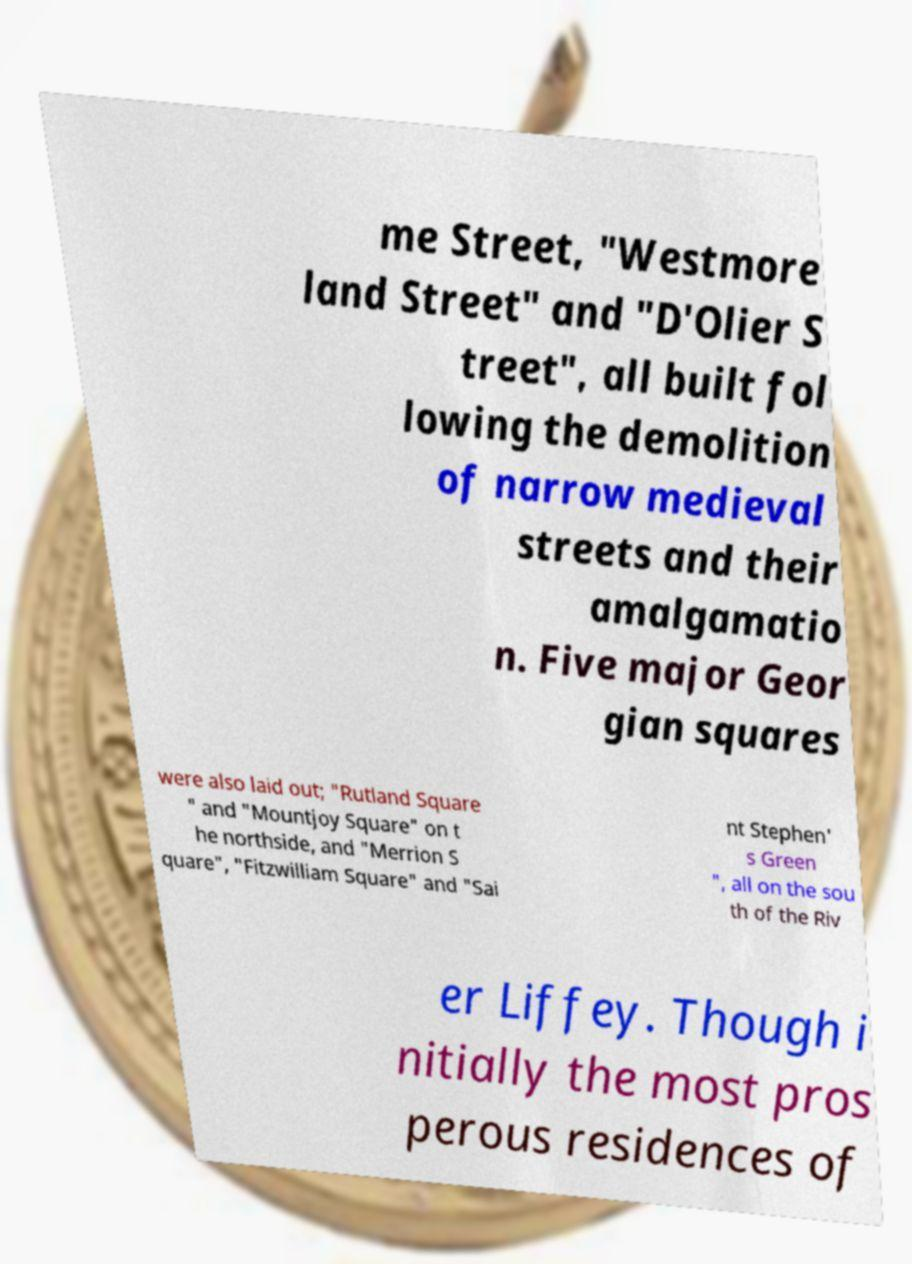For documentation purposes, I need the text within this image transcribed. Could you provide that? me Street, "Westmore land Street" and "D'Olier S treet", all built fol lowing the demolition of narrow medieval streets and their amalgamatio n. Five major Geor gian squares were also laid out; "Rutland Square " and "Mountjoy Square" on t he northside, and "Merrion S quare", "Fitzwilliam Square" and "Sai nt Stephen' s Green ", all on the sou th of the Riv er Liffey. Though i nitially the most pros perous residences of 